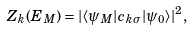<formula> <loc_0><loc_0><loc_500><loc_500>Z _ { k } ( E _ { M } ) = | \langle \psi _ { M } | c _ { k \sigma } | \psi _ { 0 } \rangle | ^ { 2 } ,</formula> 